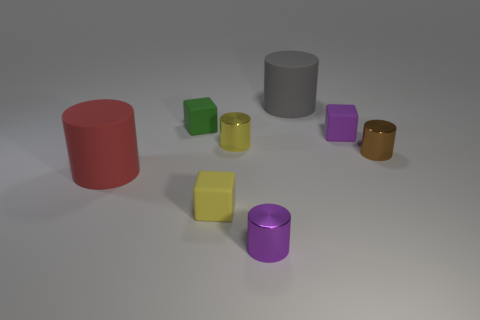What shape is the yellow object that is in front of the yellow metal object?
Provide a succinct answer. Cube. How many yellow things have the same shape as the purple metallic object?
Provide a short and direct response. 1. Are there an equal number of gray matte cylinders that are in front of the tiny green rubber thing and small yellow rubber objects behind the yellow matte block?
Provide a succinct answer. Yes. Are there any tiny green cubes that have the same material as the red thing?
Keep it short and to the point. Yes. Is the green cube made of the same material as the brown cylinder?
Give a very brief answer. No. How many red things are metallic things or rubber things?
Make the answer very short. 1. Are there more tiny shiny cylinders in front of the purple shiny thing than tiny yellow shiny cylinders?
Give a very brief answer. No. The brown cylinder has what size?
Provide a short and direct response. Small. How many things are either rubber cylinders or cubes behind the yellow cylinder?
Your response must be concise. 4. There is a matte cylinder that is in front of the block that is behind the purple rubber thing; how many cubes are behind it?
Your answer should be very brief. 2. 